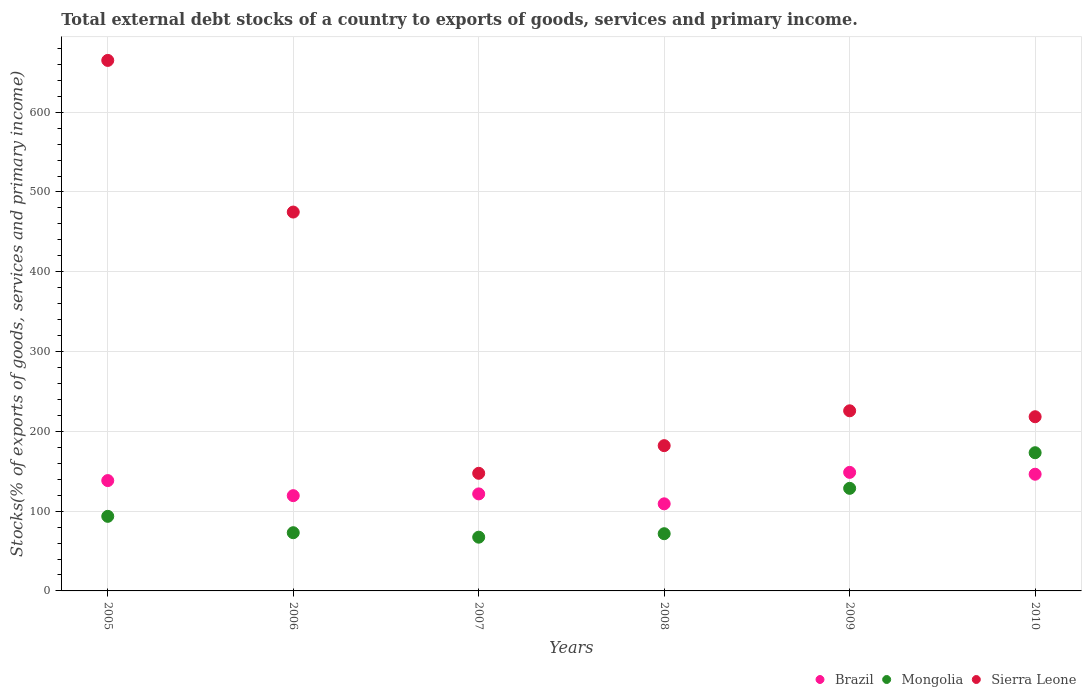Is the number of dotlines equal to the number of legend labels?
Offer a terse response. Yes. What is the total debt stocks in Brazil in 2010?
Provide a short and direct response. 146.26. Across all years, what is the maximum total debt stocks in Sierra Leone?
Keep it short and to the point. 664.88. Across all years, what is the minimum total debt stocks in Mongolia?
Offer a terse response. 67.36. In which year was the total debt stocks in Sierra Leone maximum?
Ensure brevity in your answer.  2005. In which year was the total debt stocks in Mongolia minimum?
Your answer should be very brief. 2007. What is the total total debt stocks in Mongolia in the graph?
Give a very brief answer. 607.26. What is the difference between the total debt stocks in Sierra Leone in 2005 and that in 2009?
Offer a terse response. 439.14. What is the difference between the total debt stocks in Sierra Leone in 2006 and the total debt stocks in Brazil in 2007?
Your response must be concise. 353.24. What is the average total debt stocks in Sierra Leone per year?
Ensure brevity in your answer.  318.87. In the year 2008, what is the difference between the total debt stocks in Mongolia and total debt stocks in Sierra Leone?
Your answer should be compact. -110.36. In how many years, is the total debt stocks in Brazil greater than 40 %?
Keep it short and to the point. 6. What is the ratio of the total debt stocks in Mongolia in 2008 to that in 2009?
Keep it short and to the point. 0.56. Is the difference between the total debt stocks in Mongolia in 2005 and 2009 greater than the difference between the total debt stocks in Sierra Leone in 2005 and 2009?
Offer a very short reply. No. What is the difference between the highest and the second highest total debt stocks in Brazil?
Keep it short and to the point. 2.32. What is the difference between the highest and the lowest total debt stocks in Sierra Leone?
Your response must be concise. 517.48. In how many years, is the total debt stocks in Mongolia greater than the average total debt stocks in Mongolia taken over all years?
Your answer should be compact. 2. How many years are there in the graph?
Offer a terse response. 6. Are the values on the major ticks of Y-axis written in scientific E-notation?
Provide a short and direct response. No. Where does the legend appear in the graph?
Your response must be concise. Bottom right. What is the title of the graph?
Provide a short and direct response. Total external debt stocks of a country to exports of goods, services and primary income. What is the label or title of the Y-axis?
Keep it short and to the point. Stocks(% of exports of goods, services and primary income). What is the Stocks(% of exports of goods, services and primary income) of Brazil in 2005?
Provide a succinct answer. 138.29. What is the Stocks(% of exports of goods, services and primary income) of Mongolia in 2005?
Provide a succinct answer. 93.48. What is the Stocks(% of exports of goods, services and primary income) of Sierra Leone in 2005?
Ensure brevity in your answer.  664.88. What is the Stocks(% of exports of goods, services and primary income) of Brazil in 2006?
Your response must be concise. 119.39. What is the Stocks(% of exports of goods, services and primary income) in Mongolia in 2006?
Ensure brevity in your answer.  72.96. What is the Stocks(% of exports of goods, services and primary income) in Sierra Leone in 2006?
Your response must be concise. 474.84. What is the Stocks(% of exports of goods, services and primary income) of Brazil in 2007?
Your answer should be compact. 121.6. What is the Stocks(% of exports of goods, services and primary income) in Mongolia in 2007?
Make the answer very short. 67.36. What is the Stocks(% of exports of goods, services and primary income) of Sierra Leone in 2007?
Make the answer very short. 147.41. What is the Stocks(% of exports of goods, services and primary income) of Brazil in 2008?
Provide a short and direct response. 109.15. What is the Stocks(% of exports of goods, services and primary income) of Mongolia in 2008?
Give a very brief answer. 71.71. What is the Stocks(% of exports of goods, services and primary income) in Sierra Leone in 2008?
Offer a terse response. 182.07. What is the Stocks(% of exports of goods, services and primary income) of Brazil in 2009?
Provide a succinct answer. 148.58. What is the Stocks(% of exports of goods, services and primary income) in Mongolia in 2009?
Make the answer very short. 128.56. What is the Stocks(% of exports of goods, services and primary income) of Sierra Leone in 2009?
Your response must be concise. 225.75. What is the Stocks(% of exports of goods, services and primary income) in Brazil in 2010?
Offer a terse response. 146.26. What is the Stocks(% of exports of goods, services and primary income) of Mongolia in 2010?
Make the answer very short. 173.2. What is the Stocks(% of exports of goods, services and primary income) in Sierra Leone in 2010?
Provide a succinct answer. 218.31. Across all years, what is the maximum Stocks(% of exports of goods, services and primary income) of Brazil?
Offer a terse response. 148.58. Across all years, what is the maximum Stocks(% of exports of goods, services and primary income) in Mongolia?
Make the answer very short. 173.2. Across all years, what is the maximum Stocks(% of exports of goods, services and primary income) in Sierra Leone?
Your answer should be compact. 664.88. Across all years, what is the minimum Stocks(% of exports of goods, services and primary income) of Brazil?
Offer a terse response. 109.15. Across all years, what is the minimum Stocks(% of exports of goods, services and primary income) of Mongolia?
Your response must be concise. 67.36. Across all years, what is the minimum Stocks(% of exports of goods, services and primary income) in Sierra Leone?
Offer a very short reply. 147.41. What is the total Stocks(% of exports of goods, services and primary income) of Brazil in the graph?
Offer a terse response. 783.27. What is the total Stocks(% of exports of goods, services and primary income) of Mongolia in the graph?
Your response must be concise. 607.26. What is the total Stocks(% of exports of goods, services and primary income) in Sierra Leone in the graph?
Offer a terse response. 1913.25. What is the difference between the Stocks(% of exports of goods, services and primary income) in Brazil in 2005 and that in 2006?
Your response must be concise. 18.9. What is the difference between the Stocks(% of exports of goods, services and primary income) in Mongolia in 2005 and that in 2006?
Ensure brevity in your answer.  20.52. What is the difference between the Stocks(% of exports of goods, services and primary income) in Sierra Leone in 2005 and that in 2006?
Your answer should be compact. 190.05. What is the difference between the Stocks(% of exports of goods, services and primary income) of Brazil in 2005 and that in 2007?
Provide a short and direct response. 16.7. What is the difference between the Stocks(% of exports of goods, services and primary income) in Mongolia in 2005 and that in 2007?
Offer a terse response. 26.12. What is the difference between the Stocks(% of exports of goods, services and primary income) of Sierra Leone in 2005 and that in 2007?
Offer a terse response. 517.48. What is the difference between the Stocks(% of exports of goods, services and primary income) in Brazil in 2005 and that in 2008?
Ensure brevity in your answer.  29.14. What is the difference between the Stocks(% of exports of goods, services and primary income) in Mongolia in 2005 and that in 2008?
Your answer should be compact. 21.77. What is the difference between the Stocks(% of exports of goods, services and primary income) in Sierra Leone in 2005 and that in 2008?
Your answer should be compact. 482.81. What is the difference between the Stocks(% of exports of goods, services and primary income) in Brazil in 2005 and that in 2009?
Provide a short and direct response. -10.29. What is the difference between the Stocks(% of exports of goods, services and primary income) of Mongolia in 2005 and that in 2009?
Provide a short and direct response. -35.08. What is the difference between the Stocks(% of exports of goods, services and primary income) of Sierra Leone in 2005 and that in 2009?
Provide a short and direct response. 439.14. What is the difference between the Stocks(% of exports of goods, services and primary income) in Brazil in 2005 and that in 2010?
Ensure brevity in your answer.  -7.97. What is the difference between the Stocks(% of exports of goods, services and primary income) of Mongolia in 2005 and that in 2010?
Keep it short and to the point. -79.72. What is the difference between the Stocks(% of exports of goods, services and primary income) of Sierra Leone in 2005 and that in 2010?
Make the answer very short. 446.58. What is the difference between the Stocks(% of exports of goods, services and primary income) in Brazil in 2006 and that in 2007?
Keep it short and to the point. -2.2. What is the difference between the Stocks(% of exports of goods, services and primary income) of Mongolia in 2006 and that in 2007?
Ensure brevity in your answer.  5.6. What is the difference between the Stocks(% of exports of goods, services and primary income) of Sierra Leone in 2006 and that in 2007?
Provide a succinct answer. 327.43. What is the difference between the Stocks(% of exports of goods, services and primary income) of Brazil in 2006 and that in 2008?
Give a very brief answer. 10.24. What is the difference between the Stocks(% of exports of goods, services and primary income) of Mongolia in 2006 and that in 2008?
Make the answer very short. 1.25. What is the difference between the Stocks(% of exports of goods, services and primary income) of Sierra Leone in 2006 and that in 2008?
Give a very brief answer. 292.77. What is the difference between the Stocks(% of exports of goods, services and primary income) in Brazil in 2006 and that in 2009?
Keep it short and to the point. -29.18. What is the difference between the Stocks(% of exports of goods, services and primary income) in Mongolia in 2006 and that in 2009?
Offer a very short reply. -55.61. What is the difference between the Stocks(% of exports of goods, services and primary income) of Sierra Leone in 2006 and that in 2009?
Provide a succinct answer. 249.09. What is the difference between the Stocks(% of exports of goods, services and primary income) in Brazil in 2006 and that in 2010?
Provide a succinct answer. -26.86. What is the difference between the Stocks(% of exports of goods, services and primary income) of Mongolia in 2006 and that in 2010?
Offer a terse response. -100.24. What is the difference between the Stocks(% of exports of goods, services and primary income) in Sierra Leone in 2006 and that in 2010?
Ensure brevity in your answer.  256.53. What is the difference between the Stocks(% of exports of goods, services and primary income) of Brazil in 2007 and that in 2008?
Offer a very short reply. 12.44. What is the difference between the Stocks(% of exports of goods, services and primary income) in Mongolia in 2007 and that in 2008?
Give a very brief answer. -4.35. What is the difference between the Stocks(% of exports of goods, services and primary income) of Sierra Leone in 2007 and that in 2008?
Make the answer very short. -34.66. What is the difference between the Stocks(% of exports of goods, services and primary income) of Brazil in 2007 and that in 2009?
Your answer should be compact. -26.98. What is the difference between the Stocks(% of exports of goods, services and primary income) in Mongolia in 2007 and that in 2009?
Your answer should be compact. -61.21. What is the difference between the Stocks(% of exports of goods, services and primary income) of Sierra Leone in 2007 and that in 2009?
Your response must be concise. -78.34. What is the difference between the Stocks(% of exports of goods, services and primary income) in Brazil in 2007 and that in 2010?
Make the answer very short. -24.66. What is the difference between the Stocks(% of exports of goods, services and primary income) in Mongolia in 2007 and that in 2010?
Ensure brevity in your answer.  -105.84. What is the difference between the Stocks(% of exports of goods, services and primary income) of Sierra Leone in 2007 and that in 2010?
Offer a terse response. -70.9. What is the difference between the Stocks(% of exports of goods, services and primary income) of Brazil in 2008 and that in 2009?
Your answer should be compact. -39.42. What is the difference between the Stocks(% of exports of goods, services and primary income) in Mongolia in 2008 and that in 2009?
Provide a short and direct response. -56.86. What is the difference between the Stocks(% of exports of goods, services and primary income) of Sierra Leone in 2008 and that in 2009?
Provide a succinct answer. -43.68. What is the difference between the Stocks(% of exports of goods, services and primary income) of Brazil in 2008 and that in 2010?
Your answer should be very brief. -37.1. What is the difference between the Stocks(% of exports of goods, services and primary income) of Mongolia in 2008 and that in 2010?
Make the answer very short. -101.49. What is the difference between the Stocks(% of exports of goods, services and primary income) of Sierra Leone in 2008 and that in 2010?
Keep it short and to the point. -36.24. What is the difference between the Stocks(% of exports of goods, services and primary income) of Brazil in 2009 and that in 2010?
Keep it short and to the point. 2.32. What is the difference between the Stocks(% of exports of goods, services and primary income) in Mongolia in 2009 and that in 2010?
Provide a short and direct response. -44.63. What is the difference between the Stocks(% of exports of goods, services and primary income) of Sierra Leone in 2009 and that in 2010?
Give a very brief answer. 7.44. What is the difference between the Stocks(% of exports of goods, services and primary income) in Brazil in 2005 and the Stocks(% of exports of goods, services and primary income) in Mongolia in 2006?
Provide a short and direct response. 65.33. What is the difference between the Stocks(% of exports of goods, services and primary income) of Brazil in 2005 and the Stocks(% of exports of goods, services and primary income) of Sierra Leone in 2006?
Ensure brevity in your answer.  -336.54. What is the difference between the Stocks(% of exports of goods, services and primary income) of Mongolia in 2005 and the Stocks(% of exports of goods, services and primary income) of Sierra Leone in 2006?
Your answer should be very brief. -381.35. What is the difference between the Stocks(% of exports of goods, services and primary income) in Brazil in 2005 and the Stocks(% of exports of goods, services and primary income) in Mongolia in 2007?
Your answer should be compact. 70.93. What is the difference between the Stocks(% of exports of goods, services and primary income) of Brazil in 2005 and the Stocks(% of exports of goods, services and primary income) of Sierra Leone in 2007?
Provide a short and direct response. -9.12. What is the difference between the Stocks(% of exports of goods, services and primary income) in Mongolia in 2005 and the Stocks(% of exports of goods, services and primary income) in Sierra Leone in 2007?
Offer a terse response. -53.93. What is the difference between the Stocks(% of exports of goods, services and primary income) of Brazil in 2005 and the Stocks(% of exports of goods, services and primary income) of Mongolia in 2008?
Provide a short and direct response. 66.58. What is the difference between the Stocks(% of exports of goods, services and primary income) in Brazil in 2005 and the Stocks(% of exports of goods, services and primary income) in Sierra Leone in 2008?
Your response must be concise. -43.78. What is the difference between the Stocks(% of exports of goods, services and primary income) in Mongolia in 2005 and the Stocks(% of exports of goods, services and primary income) in Sierra Leone in 2008?
Ensure brevity in your answer.  -88.59. What is the difference between the Stocks(% of exports of goods, services and primary income) of Brazil in 2005 and the Stocks(% of exports of goods, services and primary income) of Mongolia in 2009?
Make the answer very short. 9.73. What is the difference between the Stocks(% of exports of goods, services and primary income) of Brazil in 2005 and the Stocks(% of exports of goods, services and primary income) of Sierra Leone in 2009?
Make the answer very short. -87.46. What is the difference between the Stocks(% of exports of goods, services and primary income) of Mongolia in 2005 and the Stocks(% of exports of goods, services and primary income) of Sierra Leone in 2009?
Your answer should be compact. -132.27. What is the difference between the Stocks(% of exports of goods, services and primary income) of Brazil in 2005 and the Stocks(% of exports of goods, services and primary income) of Mongolia in 2010?
Provide a succinct answer. -34.91. What is the difference between the Stocks(% of exports of goods, services and primary income) of Brazil in 2005 and the Stocks(% of exports of goods, services and primary income) of Sierra Leone in 2010?
Provide a short and direct response. -80.01. What is the difference between the Stocks(% of exports of goods, services and primary income) in Mongolia in 2005 and the Stocks(% of exports of goods, services and primary income) in Sierra Leone in 2010?
Provide a short and direct response. -124.82. What is the difference between the Stocks(% of exports of goods, services and primary income) of Brazil in 2006 and the Stocks(% of exports of goods, services and primary income) of Mongolia in 2007?
Give a very brief answer. 52.04. What is the difference between the Stocks(% of exports of goods, services and primary income) of Brazil in 2006 and the Stocks(% of exports of goods, services and primary income) of Sierra Leone in 2007?
Ensure brevity in your answer.  -28.01. What is the difference between the Stocks(% of exports of goods, services and primary income) of Mongolia in 2006 and the Stocks(% of exports of goods, services and primary income) of Sierra Leone in 2007?
Keep it short and to the point. -74.45. What is the difference between the Stocks(% of exports of goods, services and primary income) of Brazil in 2006 and the Stocks(% of exports of goods, services and primary income) of Mongolia in 2008?
Give a very brief answer. 47.69. What is the difference between the Stocks(% of exports of goods, services and primary income) of Brazil in 2006 and the Stocks(% of exports of goods, services and primary income) of Sierra Leone in 2008?
Offer a terse response. -62.68. What is the difference between the Stocks(% of exports of goods, services and primary income) in Mongolia in 2006 and the Stocks(% of exports of goods, services and primary income) in Sierra Leone in 2008?
Keep it short and to the point. -109.11. What is the difference between the Stocks(% of exports of goods, services and primary income) of Brazil in 2006 and the Stocks(% of exports of goods, services and primary income) of Mongolia in 2009?
Offer a very short reply. -9.17. What is the difference between the Stocks(% of exports of goods, services and primary income) in Brazil in 2006 and the Stocks(% of exports of goods, services and primary income) in Sierra Leone in 2009?
Offer a very short reply. -106.35. What is the difference between the Stocks(% of exports of goods, services and primary income) in Mongolia in 2006 and the Stocks(% of exports of goods, services and primary income) in Sierra Leone in 2009?
Ensure brevity in your answer.  -152.79. What is the difference between the Stocks(% of exports of goods, services and primary income) in Brazil in 2006 and the Stocks(% of exports of goods, services and primary income) in Mongolia in 2010?
Give a very brief answer. -53.8. What is the difference between the Stocks(% of exports of goods, services and primary income) in Brazil in 2006 and the Stocks(% of exports of goods, services and primary income) in Sierra Leone in 2010?
Your response must be concise. -98.91. What is the difference between the Stocks(% of exports of goods, services and primary income) in Mongolia in 2006 and the Stocks(% of exports of goods, services and primary income) in Sierra Leone in 2010?
Your answer should be very brief. -145.35. What is the difference between the Stocks(% of exports of goods, services and primary income) of Brazil in 2007 and the Stocks(% of exports of goods, services and primary income) of Mongolia in 2008?
Provide a succinct answer. 49.89. What is the difference between the Stocks(% of exports of goods, services and primary income) of Brazil in 2007 and the Stocks(% of exports of goods, services and primary income) of Sierra Leone in 2008?
Ensure brevity in your answer.  -60.47. What is the difference between the Stocks(% of exports of goods, services and primary income) in Mongolia in 2007 and the Stocks(% of exports of goods, services and primary income) in Sierra Leone in 2008?
Offer a terse response. -114.71. What is the difference between the Stocks(% of exports of goods, services and primary income) of Brazil in 2007 and the Stocks(% of exports of goods, services and primary income) of Mongolia in 2009?
Offer a very short reply. -6.97. What is the difference between the Stocks(% of exports of goods, services and primary income) in Brazil in 2007 and the Stocks(% of exports of goods, services and primary income) in Sierra Leone in 2009?
Your response must be concise. -104.15. What is the difference between the Stocks(% of exports of goods, services and primary income) of Mongolia in 2007 and the Stocks(% of exports of goods, services and primary income) of Sierra Leone in 2009?
Your response must be concise. -158.39. What is the difference between the Stocks(% of exports of goods, services and primary income) in Brazil in 2007 and the Stocks(% of exports of goods, services and primary income) in Mongolia in 2010?
Offer a very short reply. -51.6. What is the difference between the Stocks(% of exports of goods, services and primary income) of Brazil in 2007 and the Stocks(% of exports of goods, services and primary income) of Sierra Leone in 2010?
Provide a short and direct response. -96.71. What is the difference between the Stocks(% of exports of goods, services and primary income) of Mongolia in 2007 and the Stocks(% of exports of goods, services and primary income) of Sierra Leone in 2010?
Keep it short and to the point. -150.95. What is the difference between the Stocks(% of exports of goods, services and primary income) in Brazil in 2008 and the Stocks(% of exports of goods, services and primary income) in Mongolia in 2009?
Keep it short and to the point. -19.41. What is the difference between the Stocks(% of exports of goods, services and primary income) in Brazil in 2008 and the Stocks(% of exports of goods, services and primary income) in Sierra Leone in 2009?
Your answer should be very brief. -116.59. What is the difference between the Stocks(% of exports of goods, services and primary income) in Mongolia in 2008 and the Stocks(% of exports of goods, services and primary income) in Sierra Leone in 2009?
Give a very brief answer. -154.04. What is the difference between the Stocks(% of exports of goods, services and primary income) of Brazil in 2008 and the Stocks(% of exports of goods, services and primary income) of Mongolia in 2010?
Your answer should be very brief. -64.04. What is the difference between the Stocks(% of exports of goods, services and primary income) in Brazil in 2008 and the Stocks(% of exports of goods, services and primary income) in Sierra Leone in 2010?
Keep it short and to the point. -109.15. What is the difference between the Stocks(% of exports of goods, services and primary income) in Mongolia in 2008 and the Stocks(% of exports of goods, services and primary income) in Sierra Leone in 2010?
Provide a short and direct response. -146.6. What is the difference between the Stocks(% of exports of goods, services and primary income) of Brazil in 2009 and the Stocks(% of exports of goods, services and primary income) of Mongolia in 2010?
Provide a short and direct response. -24.62. What is the difference between the Stocks(% of exports of goods, services and primary income) of Brazil in 2009 and the Stocks(% of exports of goods, services and primary income) of Sierra Leone in 2010?
Ensure brevity in your answer.  -69.73. What is the difference between the Stocks(% of exports of goods, services and primary income) in Mongolia in 2009 and the Stocks(% of exports of goods, services and primary income) in Sierra Leone in 2010?
Make the answer very short. -89.74. What is the average Stocks(% of exports of goods, services and primary income) of Brazil per year?
Offer a very short reply. 130.55. What is the average Stocks(% of exports of goods, services and primary income) of Mongolia per year?
Provide a succinct answer. 101.21. What is the average Stocks(% of exports of goods, services and primary income) in Sierra Leone per year?
Your answer should be very brief. 318.87. In the year 2005, what is the difference between the Stocks(% of exports of goods, services and primary income) in Brazil and Stocks(% of exports of goods, services and primary income) in Mongolia?
Your answer should be very brief. 44.81. In the year 2005, what is the difference between the Stocks(% of exports of goods, services and primary income) of Brazil and Stocks(% of exports of goods, services and primary income) of Sierra Leone?
Ensure brevity in your answer.  -526.59. In the year 2005, what is the difference between the Stocks(% of exports of goods, services and primary income) of Mongolia and Stocks(% of exports of goods, services and primary income) of Sierra Leone?
Your answer should be compact. -571.4. In the year 2006, what is the difference between the Stocks(% of exports of goods, services and primary income) of Brazil and Stocks(% of exports of goods, services and primary income) of Mongolia?
Ensure brevity in your answer.  46.44. In the year 2006, what is the difference between the Stocks(% of exports of goods, services and primary income) of Brazil and Stocks(% of exports of goods, services and primary income) of Sierra Leone?
Ensure brevity in your answer.  -355.44. In the year 2006, what is the difference between the Stocks(% of exports of goods, services and primary income) of Mongolia and Stocks(% of exports of goods, services and primary income) of Sierra Leone?
Give a very brief answer. -401.88. In the year 2007, what is the difference between the Stocks(% of exports of goods, services and primary income) of Brazil and Stocks(% of exports of goods, services and primary income) of Mongolia?
Offer a very short reply. 54.24. In the year 2007, what is the difference between the Stocks(% of exports of goods, services and primary income) of Brazil and Stocks(% of exports of goods, services and primary income) of Sierra Leone?
Make the answer very short. -25.81. In the year 2007, what is the difference between the Stocks(% of exports of goods, services and primary income) in Mongolia and Stocks(% of exports of goods, services and primary income) in Sierra Leone?
Your response must be concise. -80.05. In the year 2008, what is the difference between the Stocks(% of exports of goods, services and primary income) in Brazil and Stocks(% of exports of goods, services and primary income) in Mongolia?
Ensure brevity in your answer.  37.45. In the year 2008, what is the difference between the Stocks(% of exports of goods, services and primary income) of Brazil and Stocks(% of exports of goods, services and primary income) of Sierra Leone?
Your answer should be very brief. -72.92. In the year 2008, what is the difference between the Stocks(% of exports of goods, services and primary income) of Mongolia and Stocks(% of exports of goods, services and primary income) of Sierra Leone?
Your answer should be very brief. -110.36. In the year 2009, what is the difference between the Stocks(% of exports of goods, services and primary income) of Brazil and Stocks(% of exports of goods, services and primary income) of Mongolia?
Your answer should be compact. 20.01. In the year 2009, what is the difference between the Stocks(% of exports of goods, services and primary income) of Brazil and Stocks(% of exports of goods, services and primary income) of Sierra Leone?
Keep it short and to the point. -77.17. In the year 2009, what is the difference between the Stocks(% of exports of goods, services and primary income) of Mongolia and Stocks(% of exports of goods, services and primary income) of Sierra Leone?
Provide a succinct answer. -97.18. In the year 2010, what is the difference between the Stocks(% of exports of goods, services and primary income) in Brazil and Stocks(% of exports of goods, services and primary income) in Mongolia?
Provide a succinct answer. -26.94. In the year 2010, what is the difference between the Stocks(% of exports of goods, services and primary income) in Brazil and Stocks(% of exports of goods, services and primary income) in Sierra Leone?
Ensure brevity in your answer.  -72.05. In the year 2010, what is the difference between the Stocks(% of exports of goods, services and primary income) of Mongolia and Stocks(% of exports of goods, services and primary income) of Sierra Leone?
Your answer should be compact. -45.11. What is the ratio of the Stocks(% of exports of goods, services and primary income) of Brazil in 2005 to that in 2006?
Provide a succinct answer. 1.16. What is the ratio of the Stocks(% of exports of goods, services and primary income) of Mongolia in 2005 to that in 2006?
Your answer should be very brief. 1.28. What is the ratio of the Stocks(% of exports of goods, services and primary income) of Sierra Leone in 2005 to that in 2006?
Give a very brief answer. 1.4. What is the ratio of the Stocks(% of exports of goods, services and primary income) of Brazil in 2005 to that in 2007?
Offer a terse response. 1.14. What is the ratio of the Stocks(% of exports of goods, services and primary income) of Mongolia in 2005 to that in 2007?
Your response must be concise. 1.39. What is the ratio of the Stocks(% of exports of goods, services and primary income) of Sierra Leone in 2005 to that in 2007?
Give a very brief answer. 4.51. What is the ratio of the Stocks(% of exports of goods, services and primary income) of Brazil in 2005 to that in 2008?
Keep it short and to the point. 1.27. What is the ratio of the Stocks(% of exports of goods, services and primary income) in Mongolia in 2005 to that in 2008?
Your answer should be very brief. 1.3. What is the ratio of the Stocks(% of exports of goods, services and primary income) of Sierra Leone in 2005 to that in 2008?
Provide a succinct answer. 3.65. What is the ratio of the Stocks(% of exports of goods, services and primary income) of Brazil in 2005 to that in 2009?
Your answer should be compact. 0.93. What is the ratio of the Stocks(% of exports of goods, services and primary income) in Mongolia in 2005 to that in 2009?
Provide a succinct answer. 0.73. What is the ratio of the Stocks(% of exports of goods, services and primary income) of Sierra Leone in 2005 to that in 2009?
Your answer should be very brief. 2.95. What is the ratio of the Stocks(% of exports of goods, services and primary income) in Brazil in 2005 to that in 2010?
Your answer should be compact. 0.95. What is the ratio of the Stocks(% of exports of goods, services and primary income) of Mongolia in 2005 to that in 2010?
Ensure brevity in your answer.  0.54. What is the ratio of the Stocks(% of exports of goods, services and primary income) in Sierra Leone in 2005 to that in 2010?
Offer a terse response. 3.05. What is the ratio of the Stocks(% of exports of goods, services and primary income) of Brazil in 2006 to that in 2007?
Provide a short and direct response. 0.98. What is the ratio of the Stocks(% of exports of goods, services and primary income) in Mongolia in 2006 to that in 2007?
Keep it short and to the point. 1.08. What is the ratio of the Stocks(% of exports of goods, services and primary income) of Sierra Leone in 2006 to that in 2007?
Ensure brevity in your answer.  3.22. What is the ratio of the Stocks(% of exports of goods, services and primary income) in Brazil in 2006 to that in 2008?
Provide a succinct answer. 1.09. What is the ratio of the Stocks(% of exports of goods, services and primary income) of Mongolia in 2006 to that in 2008?
Offer a terse response. 1.02. What is the ratio of the Stocks(% of exports of goods, services and primary income) of Sierra Leone in 2006 to that in 2008?
Your answer should be very brief. 2.61. What is the ratio of the Stocks(% of exports of goods, services and primary income) of Brazil in 2006 to that in 2009?
Make the answer very short. 0.8. What is the ratio of the Stocks(% of exports of goods, services and primary income) of Mongolia in 2006 to that in 2009?
Your answer should be compact. 0.57. What is the ratio of the Stocks(% of exports of goods, services and primary income) in Sierra Leone in 2006 to that in 2009?
Your response must be concise. 2.1. What is the ratio of the Stocks(% of exports of goods, services and primary income) in Brazil in 2006 to that in 2010?
Keep it short and to the point. 0.82. What is the ratio of the Stocks(% of exports of goods, services and primary income) in Mongolia in 2006 to that in 2010?
Provide a short and direct response. 0.42. What is the ratio of the Stocks(% of exports of goods, services and primary income) in Sierra Leone in 2006 to that in 2010?
Give a very brief answer. 2.18. What is the ratio of the Stocks(% of exports of goods, services and primary income) in Brazil in 2007 to that in 2008?
Your answer should be compact. 1.11. What is the ratio of the Stocks(% of exports of goods, services and primary income) of Mongolia in 2007 to that in 2008?
Provide a succinct answer. 0.94. What is the ratio of the Stocks(% of exports of goods, services and primary income) in Sierra Leone in 2007 to that in 2008?
Offer a very short reply. 0.81. What is the ratio of the Stocks(% of exports of goods, services and primary income) in Brazil in 2007 to that in 2009?
Your response must be concise. 0.82. What is the ratio of the Stocks(% of exports of goods, services and primary income) in Mongolia in 2007 to that in 2009?
Provide a succinct answer. 0.52. What is the ratio of the Stocks(% of exports of goods, services and primary income) of Sierra Leone in 2007 to that in 2009?
Offer a terse response. 0.65. What is the ratio of the Stocks(% of exports of goods, services and primary income) of Brazil in 2007 to that in 2010?
Ensure brevity in your answer.  0.83. What is the ratio of the Stocks(% of exports of goods, services and primary income) of Mongolia in 2007 to that in 2010?
Offer a terse response. 0.39. What is the ratio of the Stocks(% of exports of goods, services and primary income) of Sierra Leone in 2007 to that in 2010?
Offer a terse response. 0.68. What is the ratio of the Stocks(% of exports of goods, services and primary income) in Brazil in 2008 to that in 2009?
Ensure brevity in your answer.  0.73. What is the ratio of the Stocks(% of exports of goods, services and primary income) in Mongolia in 2008 to that in 2009?
Keep it short and to the point. 0.56. What is the ratio of the Stocks(% of exports of goods, services and primary income) in Sierra Leone in 2008 to that in 2009?
Your answer should be compact. 0.81. What is the ratio of the Stocks(% of exports of goods, services and primary income) in Brazil in 2008 to that in 2010?
Offer a very short reply. 0.75. What is the ratio of the Stocks(% of exports of goods, services and primary income) of Mongolia in 2008 to that in 2010?
Offer a terse response. 0.41. What is the ratio of the Stocks(% of exports of goods, services and primary income) of Sierra Leone in 2008 to that in 2010?
Give a very brief answer. 0.83. What is the ratio of the Stocks(% of exports of goods, services and primary income) in Brazil in 2009 to that in 2010?
Offer a terse response. 1.02. What is the ratio of the Stocks(% of exports of goods, services and primary income) of Mongolia in 2009 to that in 2010?
Keep it short and to the point. 0.74. What is the ratio of the Stocks(% of exports of goods, services and primary income) of Sierra Leone in 2009 to that in 2010?
Your response must be concise. 1.03. What is the difference between the highest and the second highest Stocks(% of exports of goods, services and primary income) of Brazil?
Your answer should be very brief. 2.32. What is the difference between the highest and the second highest Stocks(% of exports of goods, services and primary income) in Mongolia?
Give a very brief answer. 44.63. What is the difference between the highest and the second highest Stocks(% of exports of goods, services and primary income) in Sierra Leone?
Offer a terse response. 190.05. What is the difference between the highest and the lowest Stocks(% of exports of goods, services and primary income) in Brazil?
Your answer should be compact. 39.42. What is the difference between the highest and the lowest Stocks(% of exports of goods, services and primary income) of Mongolia?
Provide a succinct answer. 105.84. What is the difference between the highest and the lowest Stocks(% of exports of goods, services and primary income) in Sierra Leone?
Your answer should be very brief. 517.48. 